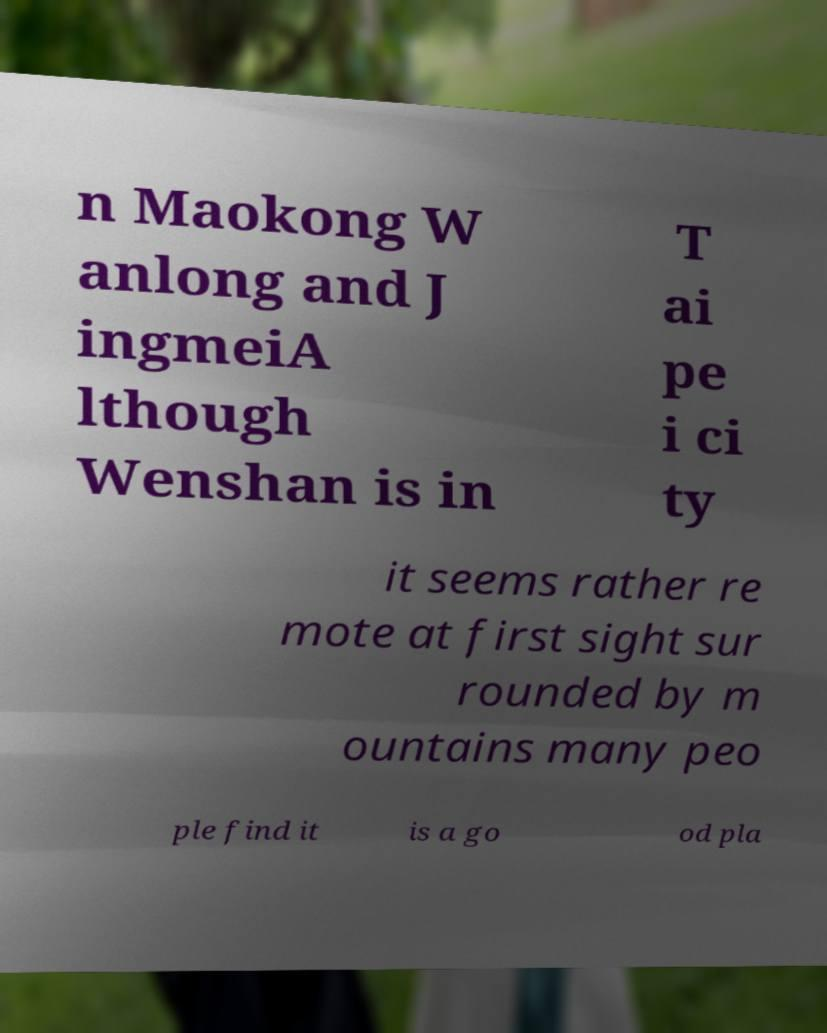I need the written content from this picture converted into text. Can you do that? n Maokong W anlong and J ingmeiA lthough Wenshan is in T ai pe i ci ty it seems rather re mote at first sight sur rounded by m ountains many peo ple find it is a go od pla 